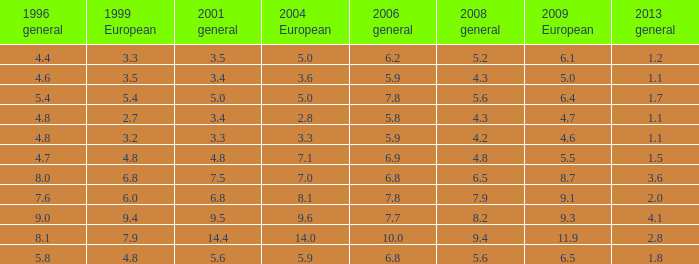What is the average value for general 2001 with more than 4.8 in 1999 European, 7.7 in 2006 general, and more than 9 in 1996 general? None. 